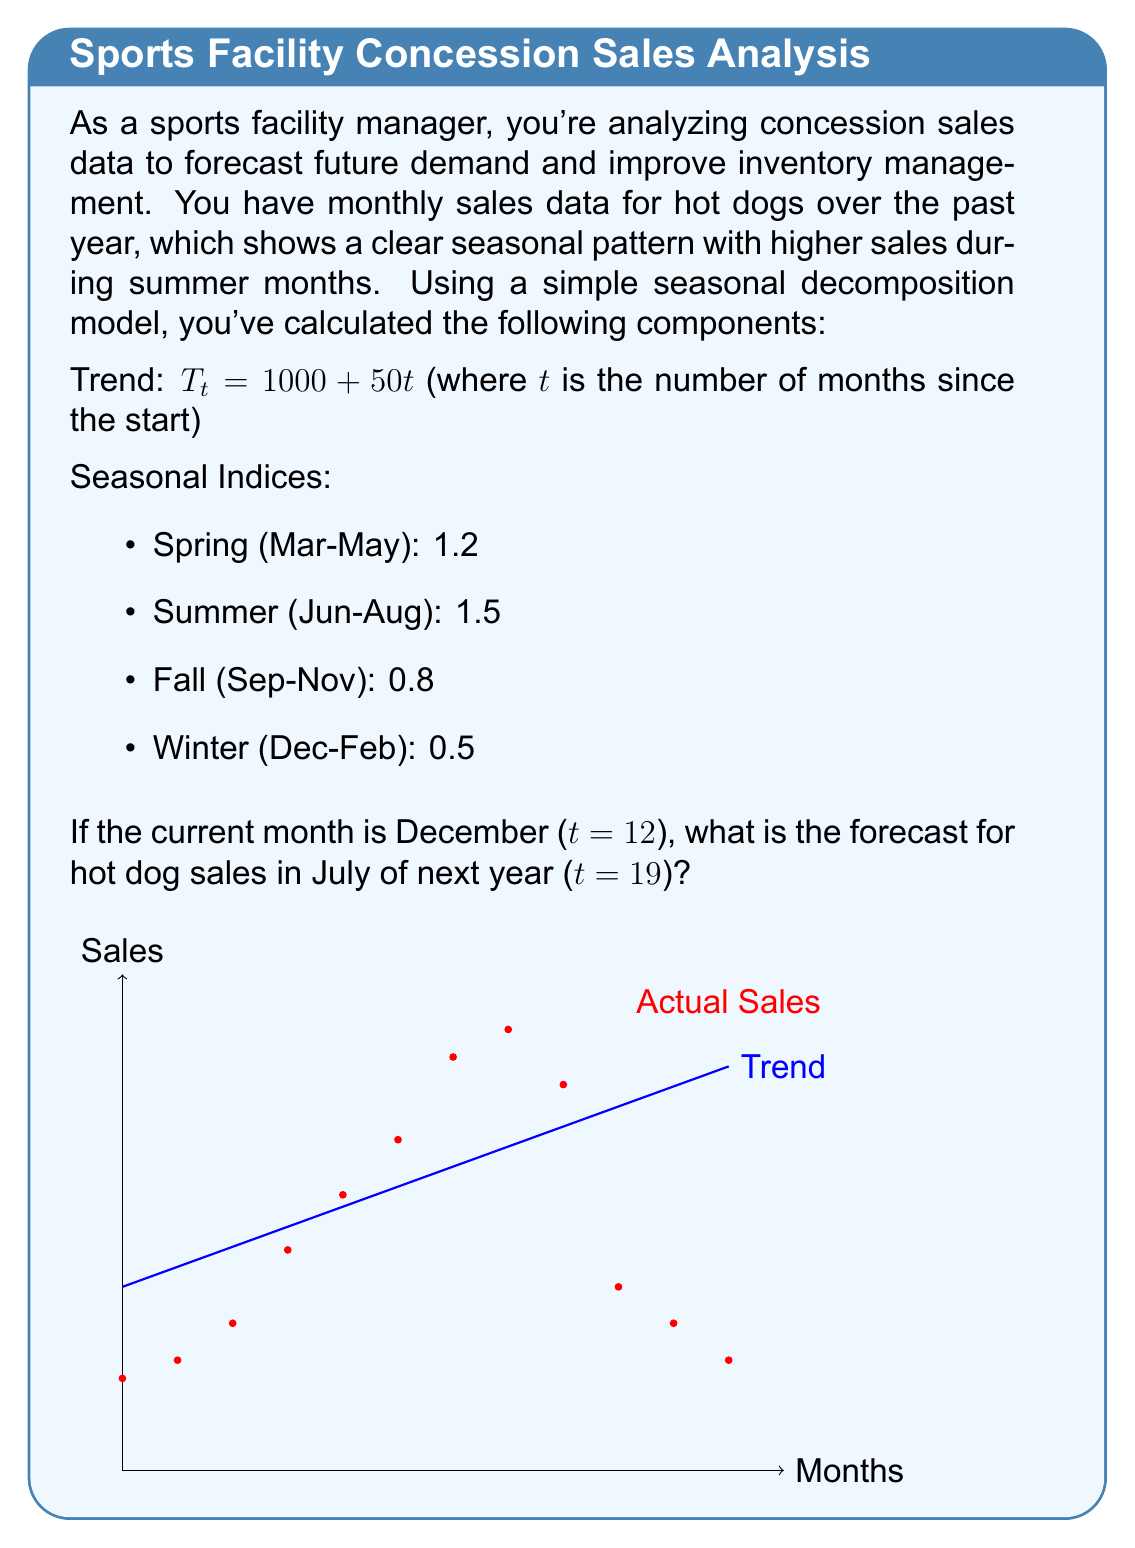Provide a solution to this math problem. To forecast hot dog sales for July next year, we'll use the multiplicative seasonal decomposition model:

$$Y_t = T_t \times S_t$$

Where:
$Y_t$ is the forecast
$T_t$ is the trend component
$S_t$ is the seasonal component

Step 1: Calculate the trend component for t=19 (July next year)
$$T_{19} = 1000 + 50(19) = 1950$$

Step 2: Identify the seasonal index for July (Summer)
$$S_{July} = 1.5$$

Step 3: Multiply the trend component by the seasonal index
$$Y_{19} = T_{19} \times S_{July} = 1950 \times 1.5 = 2925$$

Therefore, the forecast for hot dog sales in July of next year is 2,925 units.
Answer: 2,925 hot dogs 